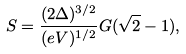Convert formula to latex. <formula><loc_0><loc_0><loc_500><loc_500>S = \frac { ( 2 \Delta ) ^ { 3 / 2 } } { ( e V ) ^ { 1 / 2 } } G ( \sqrt { 2 } - 1 ) ,</formula> 